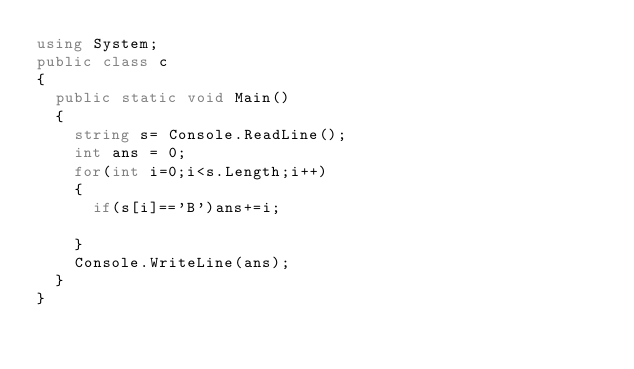<code> <loc_0><loc_0><loc_500><loc_500><_C#_>using System;
public class c
{
  public static void Main()
  {
    string s= Console.ReadLine();
    int ans = 0;
    for(int i=0;i<s.Length;i++)
    {
      if(s[i]=='B')ans+=i;
        
    }
    Console.WriteLine(ans);
  }
}</code> 